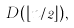<formula> <loc_0><loc_0><loc_500><loc_500>D ( \lfloor n / 2 \rfloor ) ,</formula> 